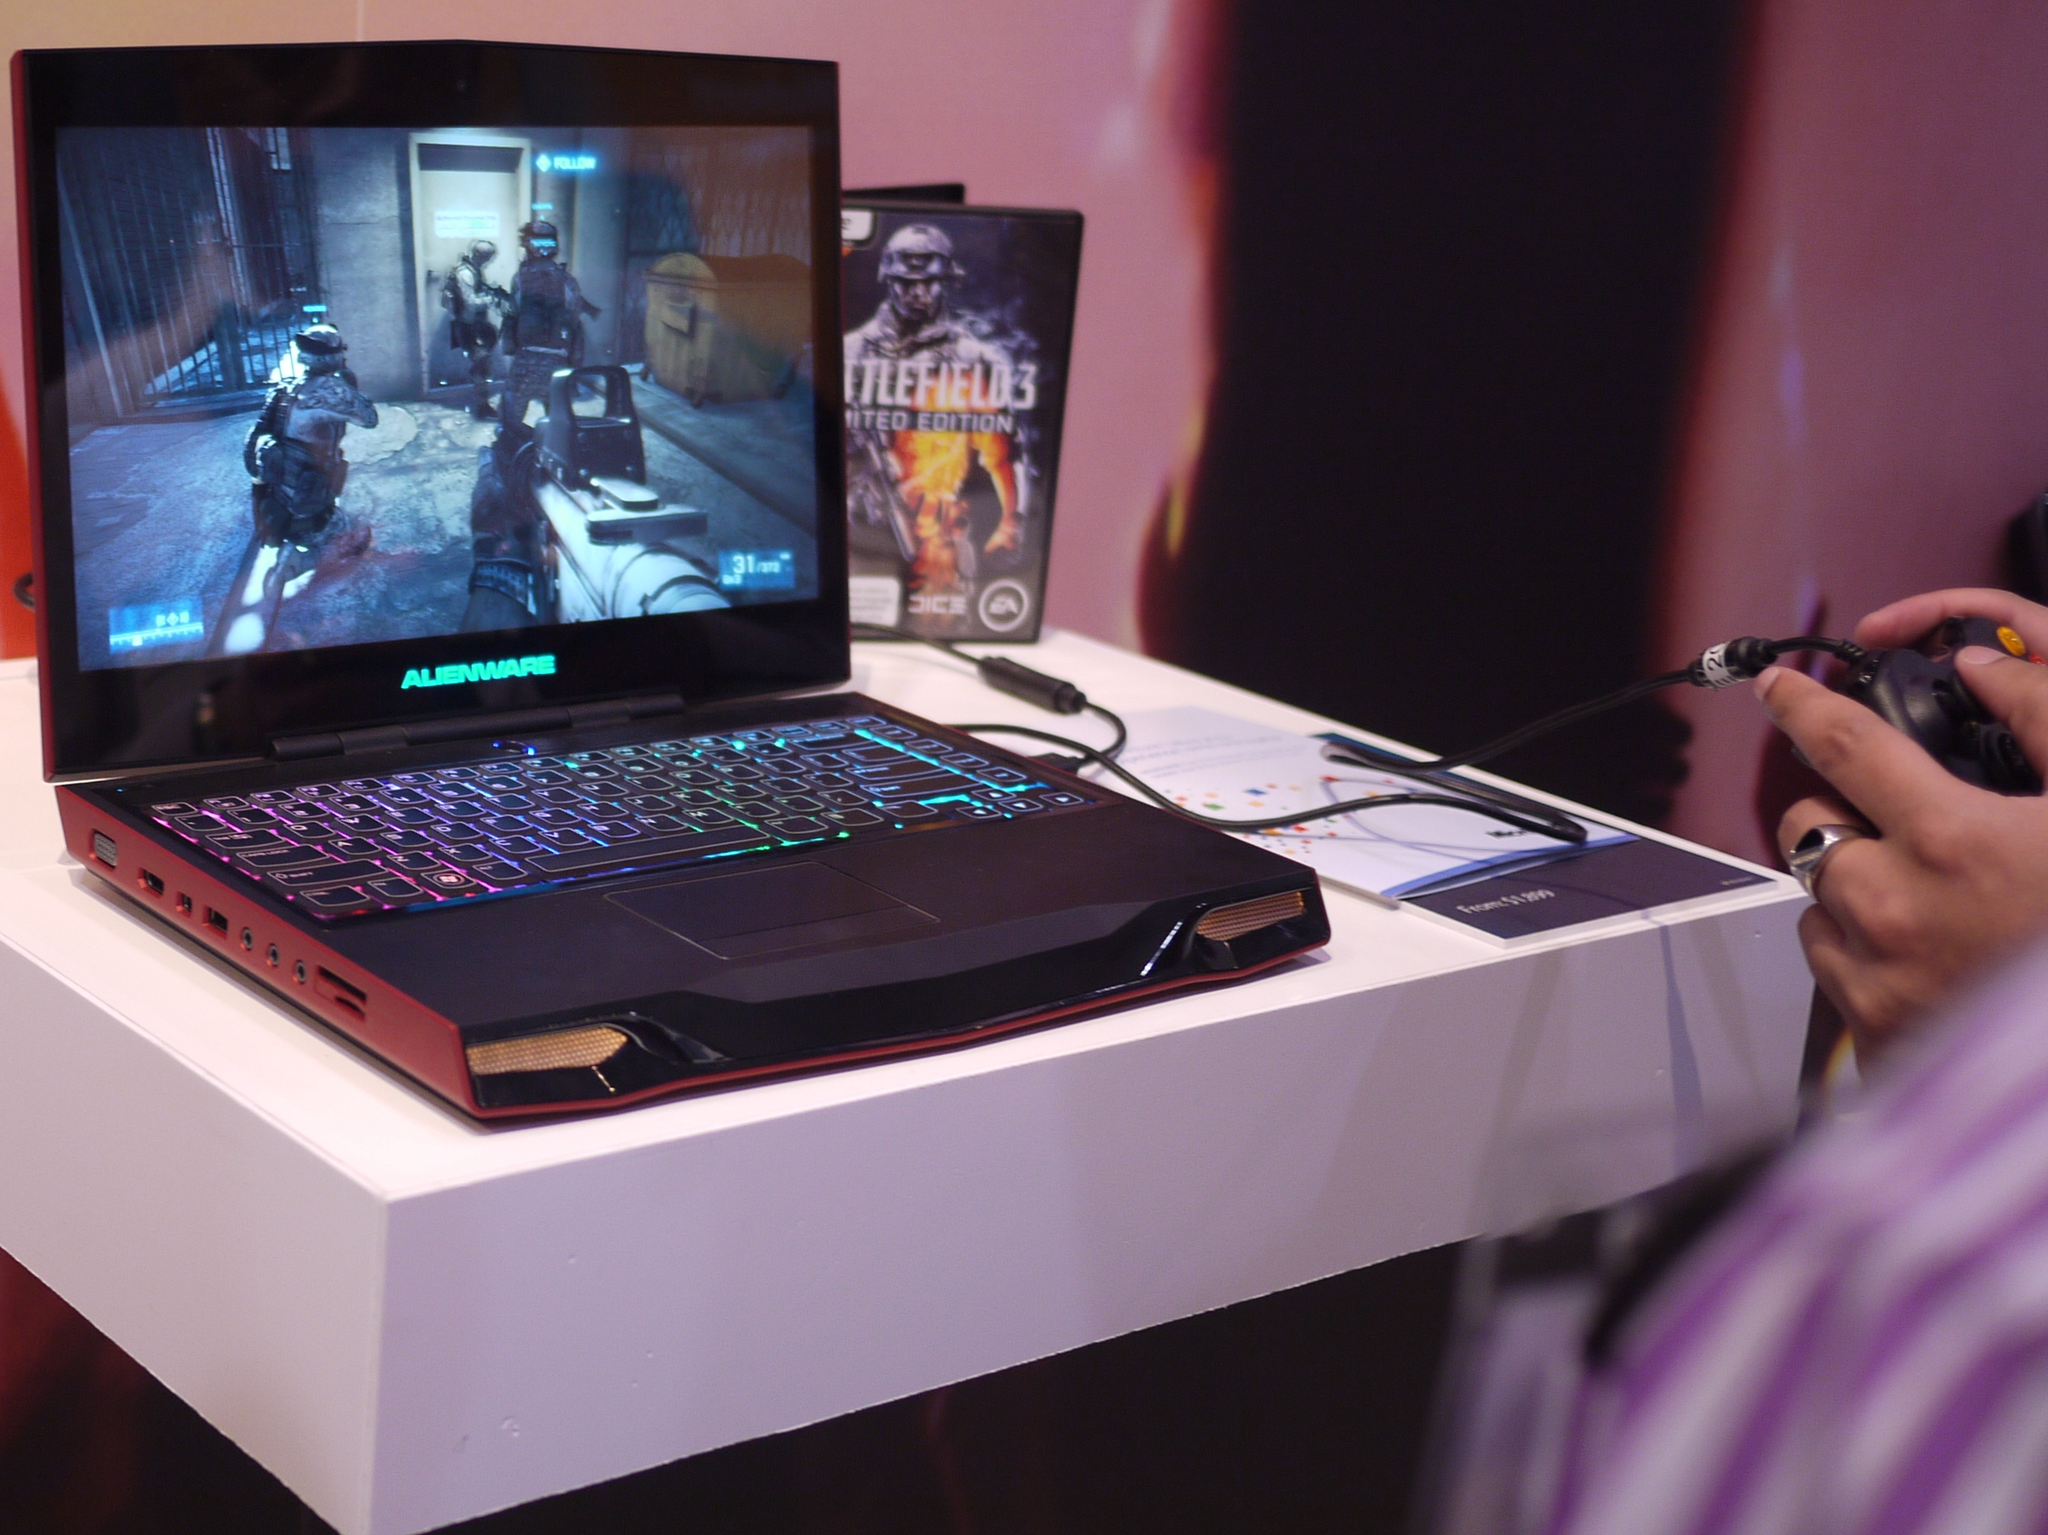<image>
Render a clear and concise summary of the photo. A copy of Battlefield 3 sits opened behind a laptop computer. 